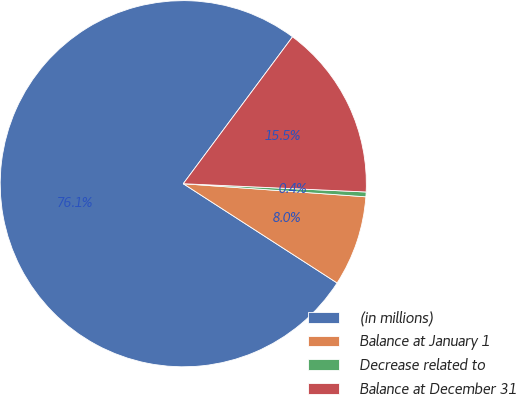Convert chart to OTSL. <chart><loc_0><loc_0><loc_500><loc_500><pie_chart><fcel>(in millions)<fcel>Balance at January 1<fcel>Decrease related to<fcel>Balance at December 31<nl><fcel>76.06%<fcel>7.98%<fcel>0.42%<fcel>15.54%<nl></chart> 